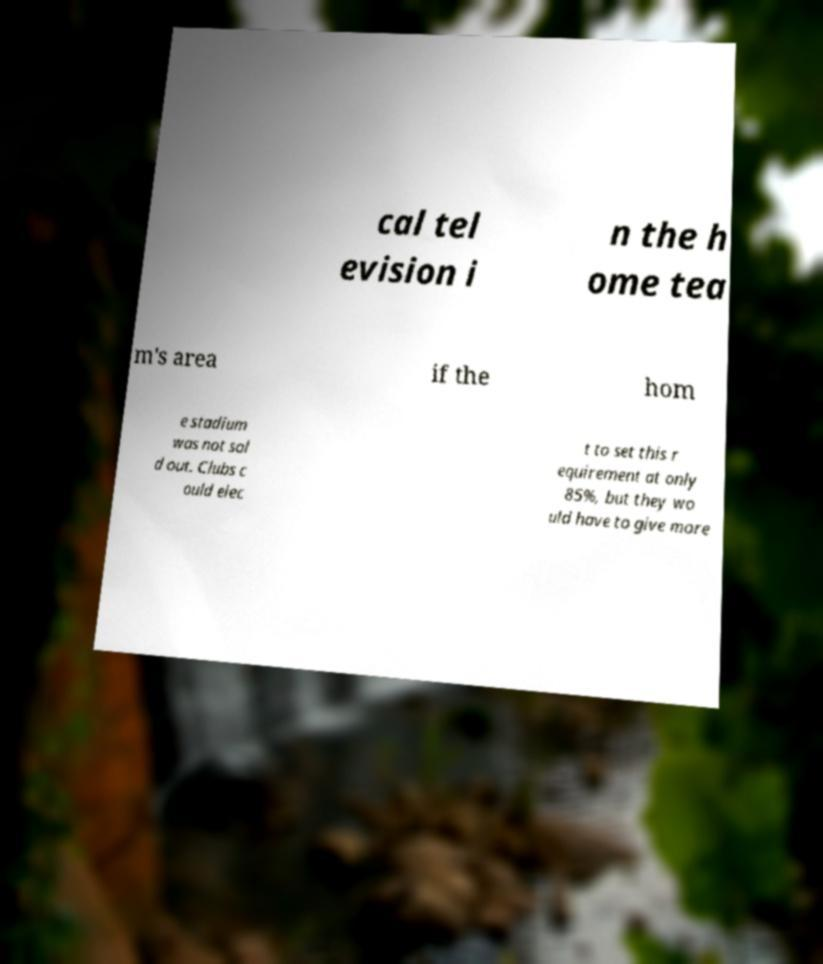I need the written content from this picture converted into text. Can you do that? cal tel evision i n the h ome tea m's area if the hom e stadium was not sol d out. Clubs c ould elec t to set this r equirement at only 85%, but they wo uld have to give more 